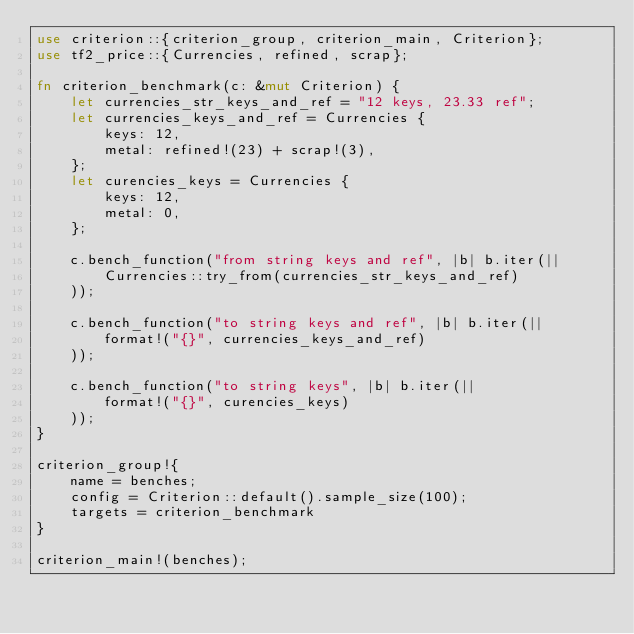Convert code to text. <code><loc_0><loc_0><loc_500><loc_500><_Rust_>use criterion::{criterion_group, criterion_main, Criterion};
use tf2_price::{Currencies, refined, scrap};

fn criterion_benchmark(c: &mut Criterion) {
    let currencies_str_keys_and_ref = "12 keys, 23.33 ref";
    let currencies_keys_and_ref = Currencies {
        keys: 12, 
        metal: refined!(23) + scrap!(3),
    };
    let curencies_keys = Currencies {
        keys: 12,
        metal: 0,
    };
    
    c.bench_function("from string keys and ref", |b| b.iter(||
        Currencies::try_from(currencies_str_keys_and_ref)
    ));
    
    c.bench_function("to string keys and ref", |b| b.iter(||
        format!("{}", currencies_keys_and_ref)
    ));
    
    c.bench_function("to string keys", |b| b.iter(||
        format!("{}", curencies_keys)
    ));
}

criterion_group!{
    name = benches;
    config = Criterion::default().sample_size(100);
    targets = criterion_benchmark
}

criterion_main!(benches);</code> 